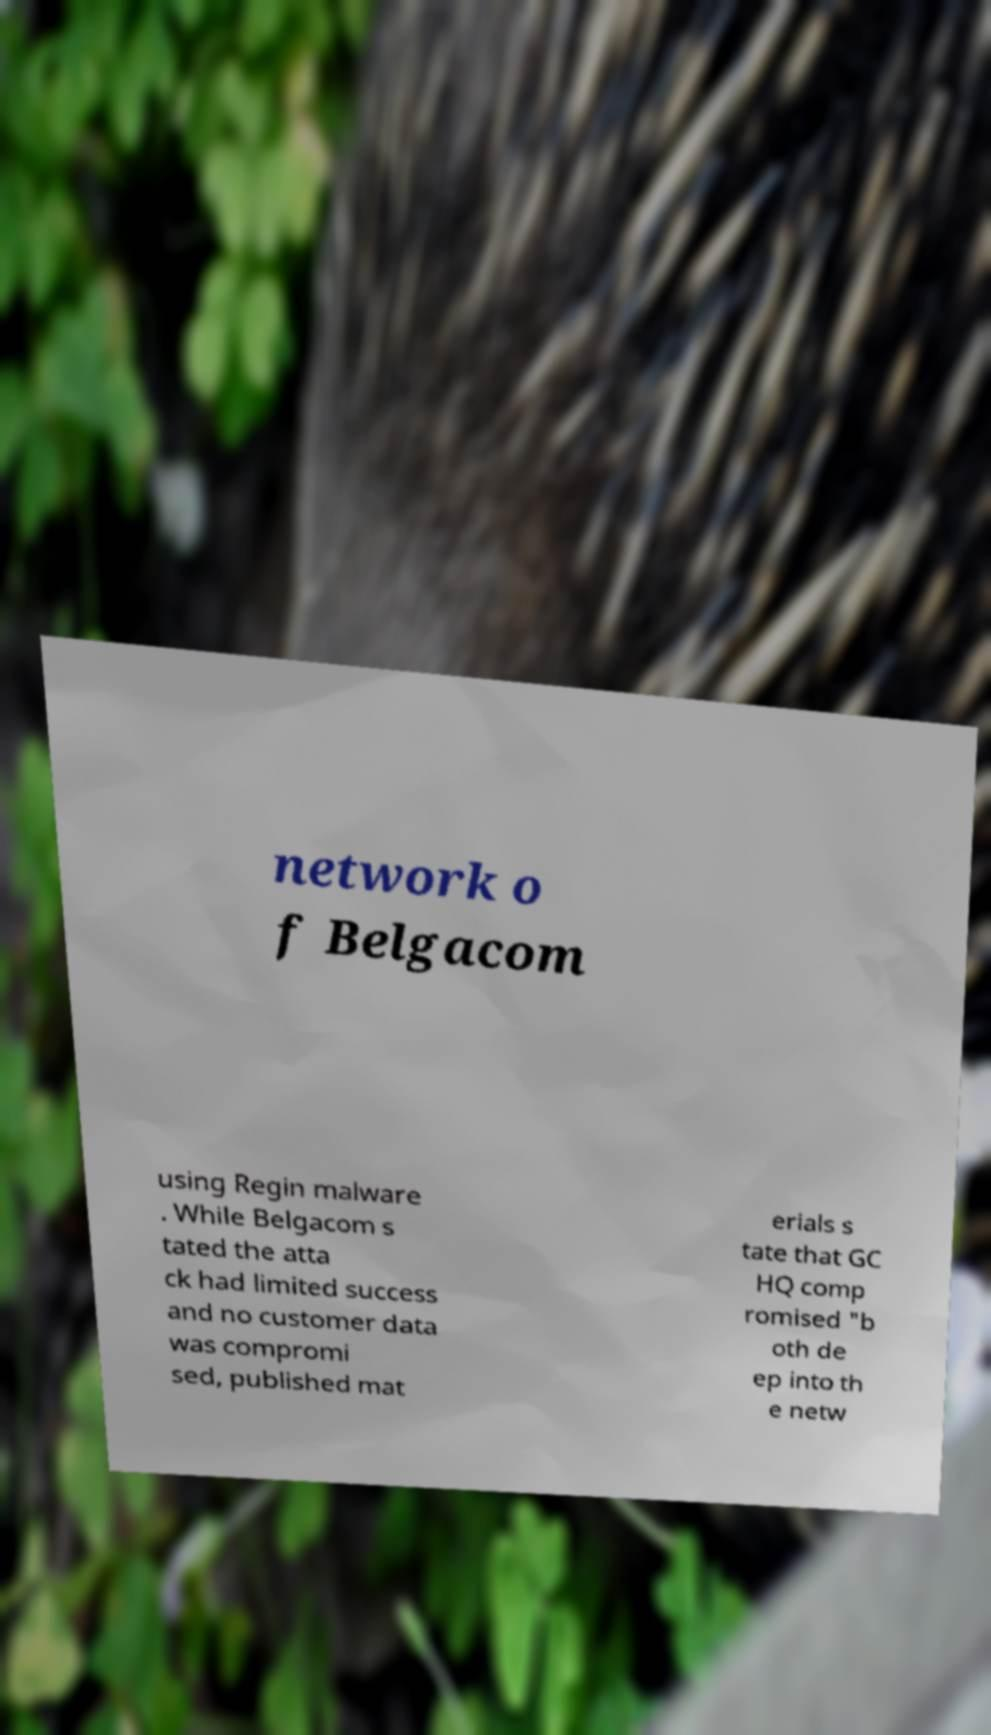Please read and relay the text visible in this image. What does it say? network o f Belgacom using Regin malware . While Belgacom s tated the atta ck had limited success and no customer data was compromi sed, published mat erials s tate that GC HQ comp romised "b oth de ep into th e netw 